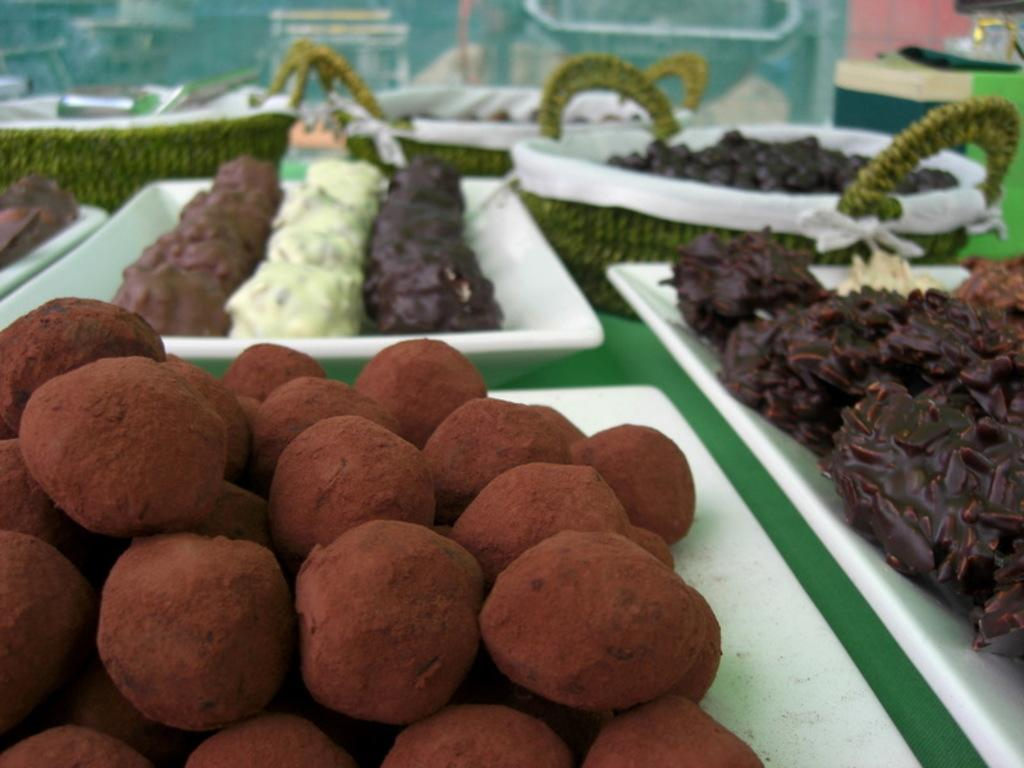What type of containers are holding food items in the image? There are trays and baskets holding food items in the image. Can you describe the food items on the trays and baskets? Unfortunately, the specific food items cannot be identified from the image. What else can be seen in the background of the image? There are other objects in the background of the image, but their details cannot be determined from the image. Are there any pets visible in the image? No, there are no pets present in the image. What type of error can be seen on the trays in the image? There is no error visible on the trays in the image. 